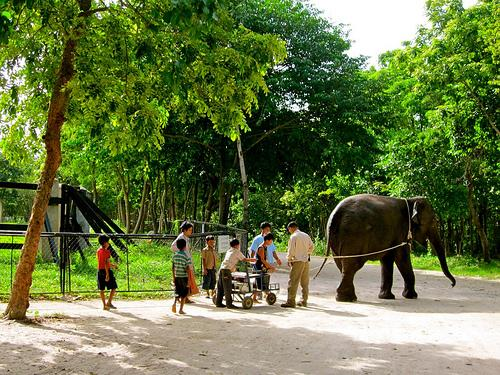Describe a boy's outfit in the scene. A boy is wearing an orange shirt, black shorts, and has a red shirt on. Tell me about the wagon in the image. A boy is pushing a metal wagon with several wheels, and it appears the wagon is attached to the cart pulled by the elephant. What is the appearance of the boy at the back of the group? The little boy at the back is wearing shorts and walking behind the others. Where is the chain link fence located in the image? The chain link fence surrounds a grassy park-like area. Explain the role of the rope in the image. The elephant has rope around its neck and is being held by it, while wearing a harness. Choose a task and explain how the image fits into it. The image fits into the referential expression grounding task, as it contains multiple elements like the elephant, children, and surroundings that can be identified and described with spatial relationships. Mention the primary action involving the elephant and children. An elephant is pulling some children and entertaining them as they play in a park. Identify the type of tree with bright green leaves in the image. The tree with bright green leaves is a tall, skinny tree leaning slightly to the right. What is the man doing near the elephant? The man is standing next to an elephant, talking to a group of kids. What is the young boy seen walking on? The young boy is walking outside on sand. 